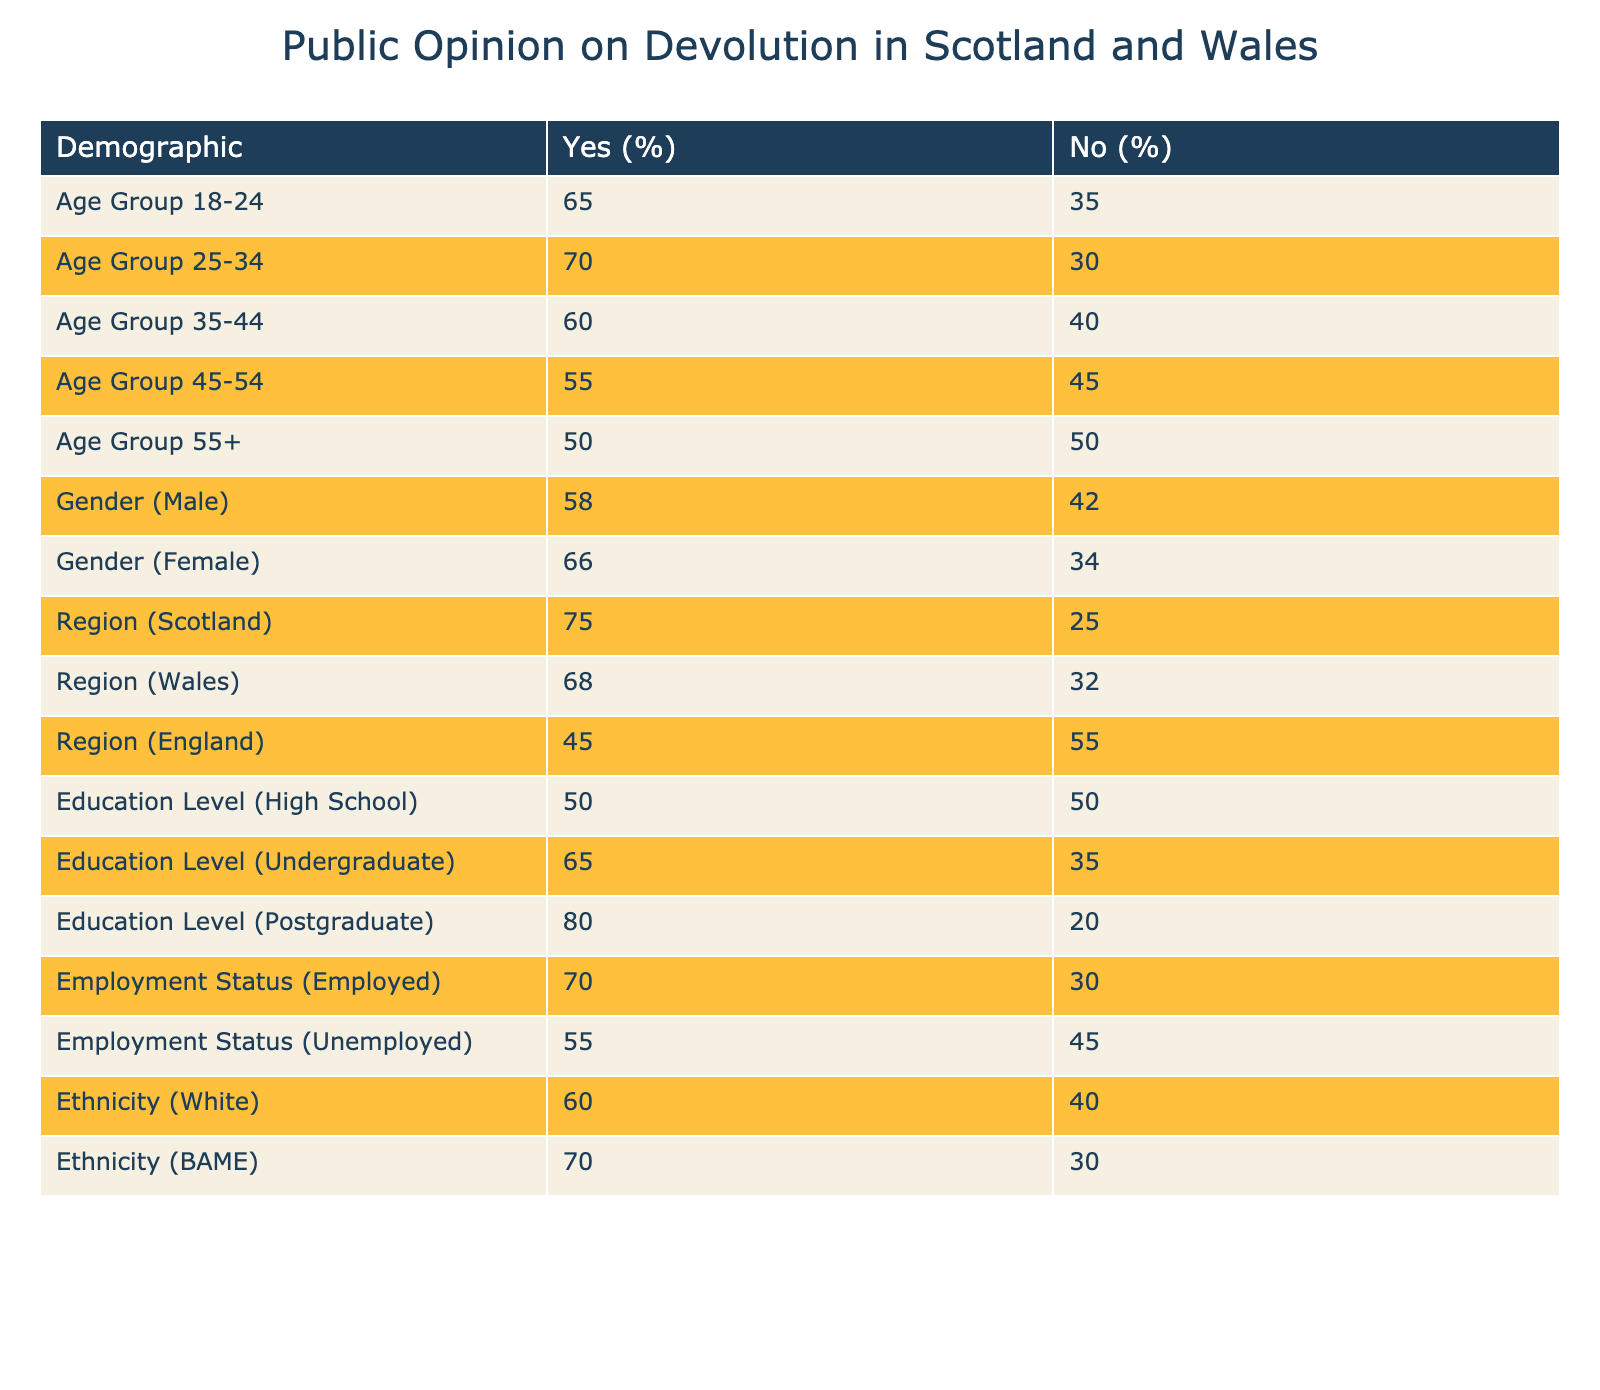What is the percentage of people aged 18-24 who support devolution? According to the table, the row for the age group 18-24 shows that 65 individuals support devolution out of a total of 100 (65 yes, 35 no). To find the percentage, we use the formula: (65/100)*100 = 65%.
Answer: 65% Which demographic has the highest percentage of devolution support? From the table, we can check each demographic's support percentage. The demographic with the highest percentage is the postgraduate education level at 80%.
Answer: Postgraduate What is the difference in percentage points of devolution support between males and females? From the table, males show 58% support and females show 66% support. To find the difference, we subtract the male percentage from the female percentage: 66% - 58% = 8 percentage points.
Answer: 8 percentage points Is it true that unemployment leads to higher support for devolution compared to high school education level? The unemployment demographic shows 55% support for devolution, while the high school education level shows 50%. Thus, it is true that unemployment correlates with higher support when these two demographics are compared.
Answer: Yes What is the average percentage of devolution support for individuals aged 35-44 and those who are unemployed? The age group 35-44 shows 60% support for devolution, and the unemployment group shows 55%. To find the average: (60 + 55) / 2 = 57.5%.
Answer: 57.5% 